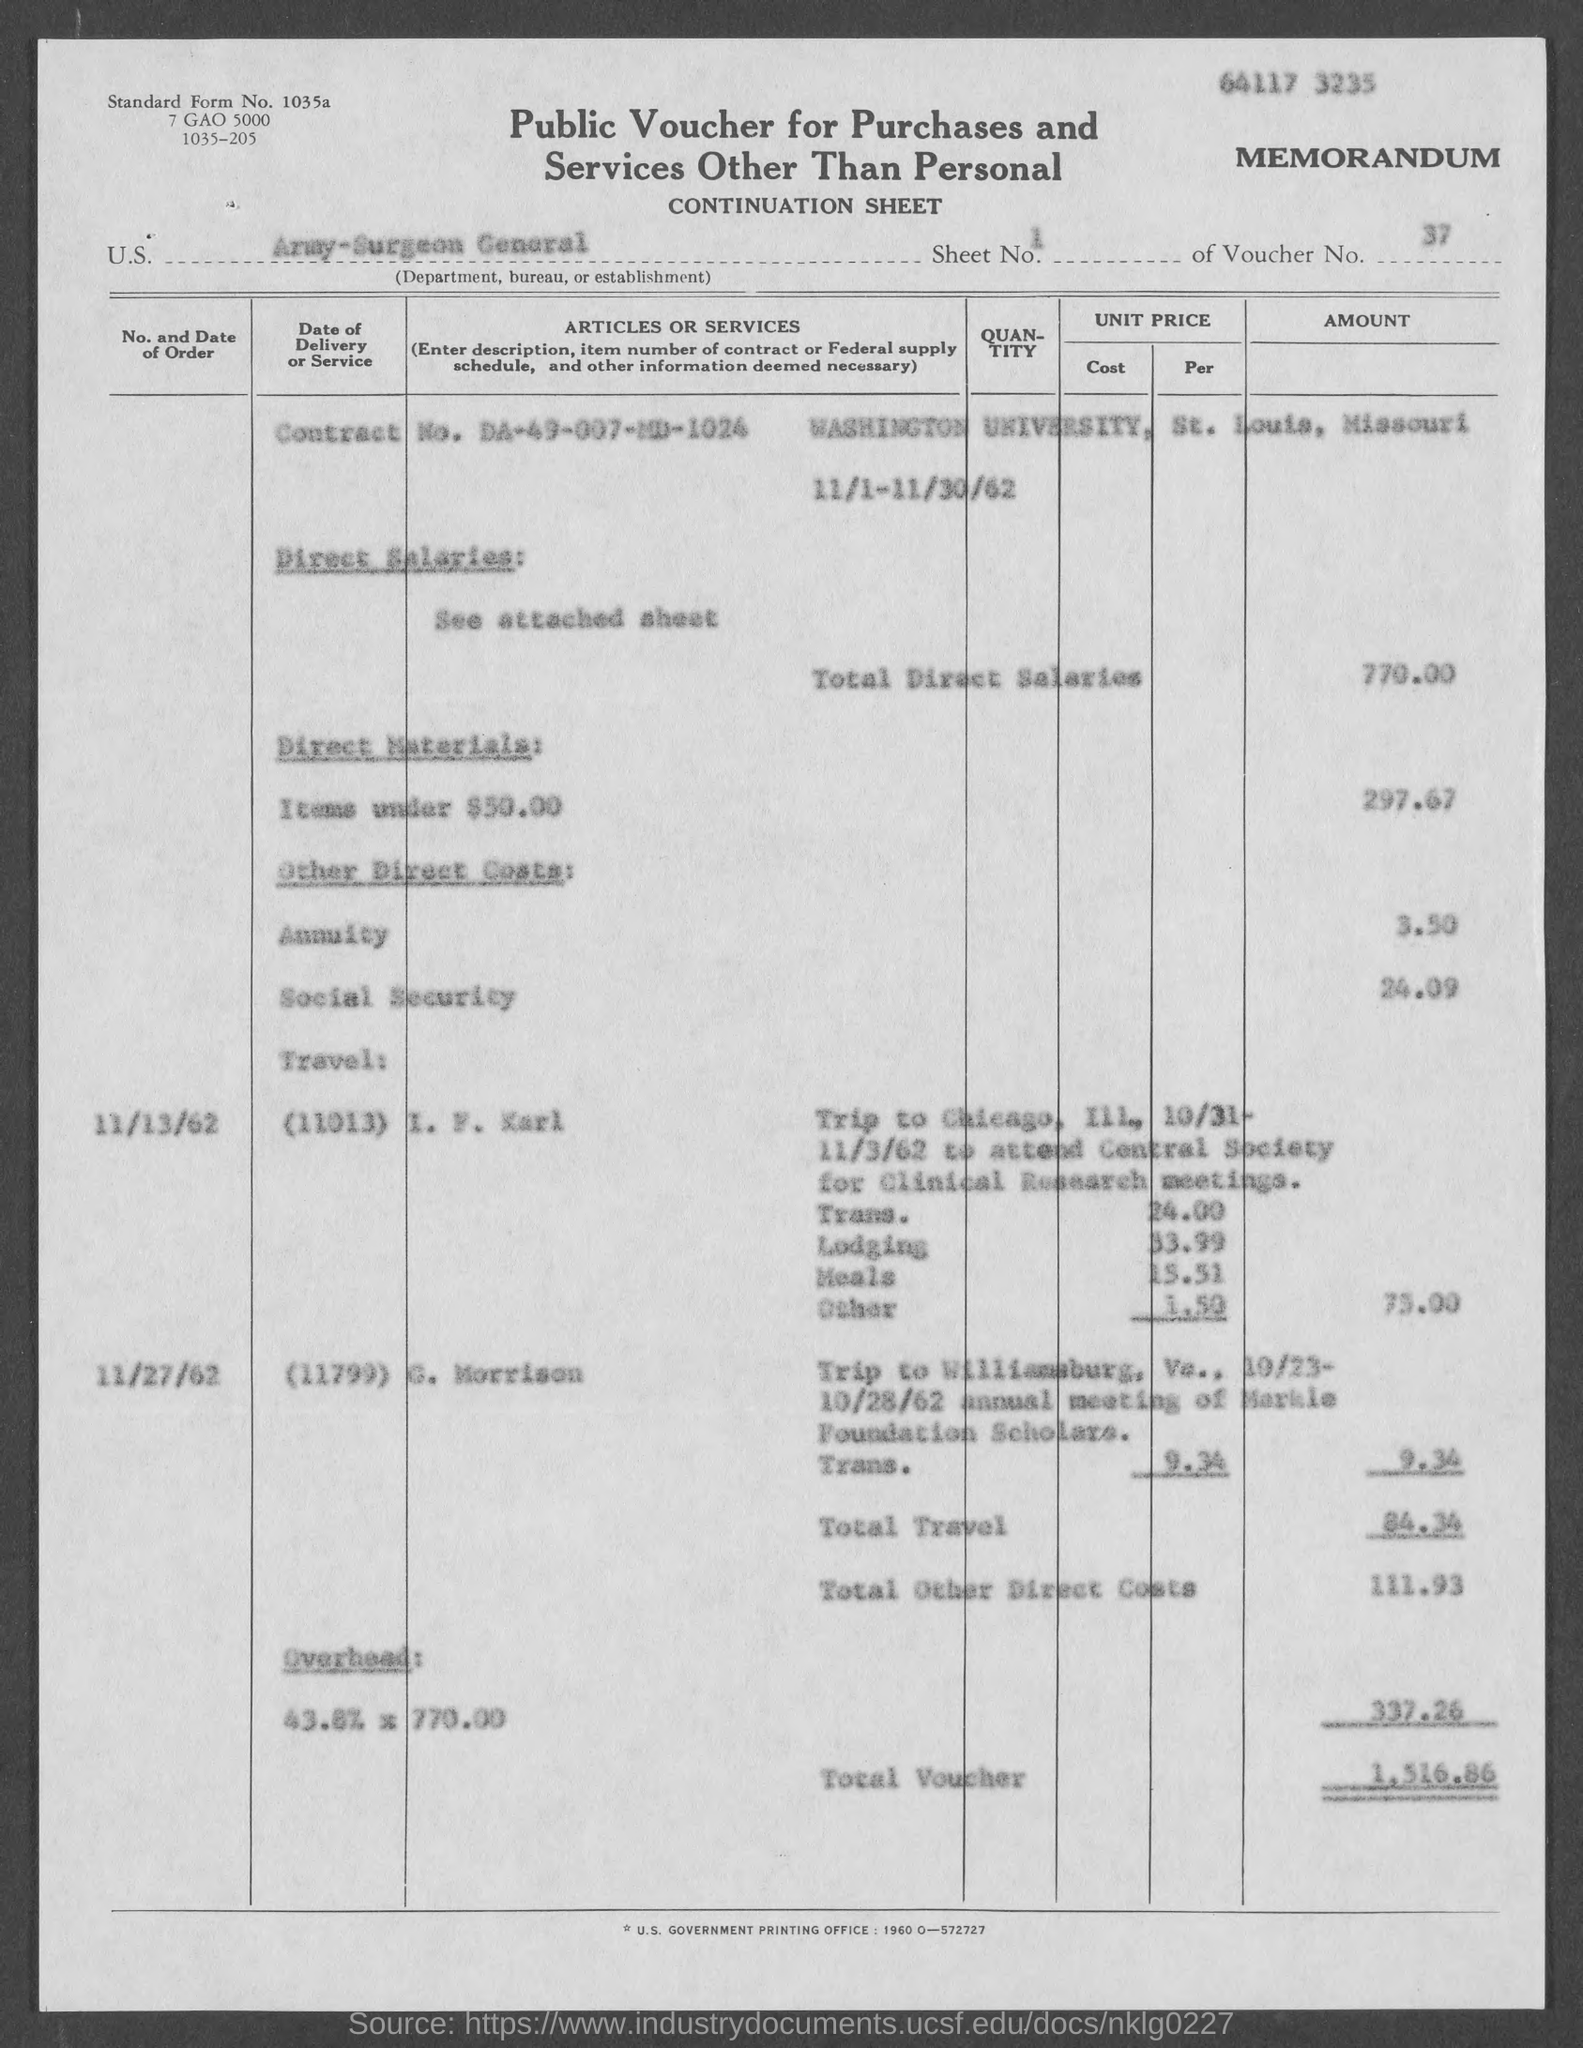what is the amount for overhead mentioned in the given form ?
 337.26 